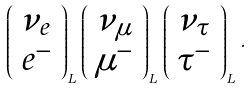Convert formula to latex. <formula><loc_0><loc_0><loc_500><loc_500>\left ( \begin{array} { c } { { \nu _ { e } } } \\ { { e ^ { - } } } \end{array} \right ) _ { L } \, \left ( \begin{array} { c } { { \nu _ { \mu } } } \\ { { \mu ^ { - } } } \end{array} \right ) _ { L } \, \left ( \begin{array} { c } { { \nu _ { \tau } } } \\ { { \tau ^ { - } } } \end{array} \right ) _ { L } \, .</formula> 